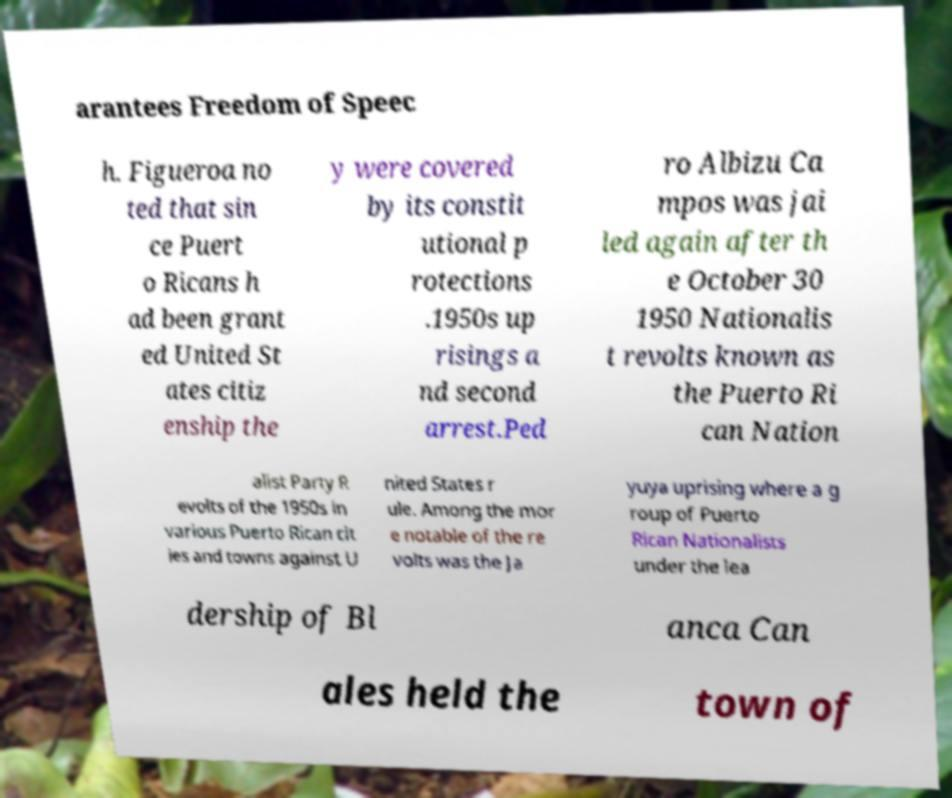For documentation purposes, I need the text within this image transcribed. Could you provide that? arantees Freedom of Speec h. Figueroa no ted that sin ce Puert o Ricans h ad been grant ed United St ates citiz enship the y were covered by its constit utional p rotections .1950s up risings a nd second arrest.Ped ro Albizu Ca mpos was jai led again after th e October 30 1950 Nationalis t revolts known as the Puerto Ri can Nation alist Party R evolts of the 1950s in various Puerto Rican cit ies and towns against U nited States r ule. Among the mor e notable of the re volts was the Ja yuya uprising where a g roup of Puerto Rican Nationalists under the lea dership of Bl anca Can ales held the town of 